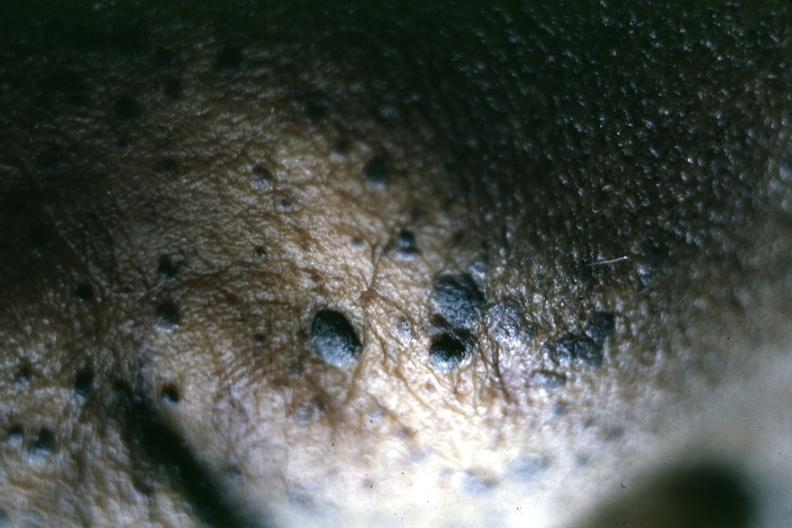s 4 month old child several slides from this case well shown?
Answer the question using a single word or phrase. No 